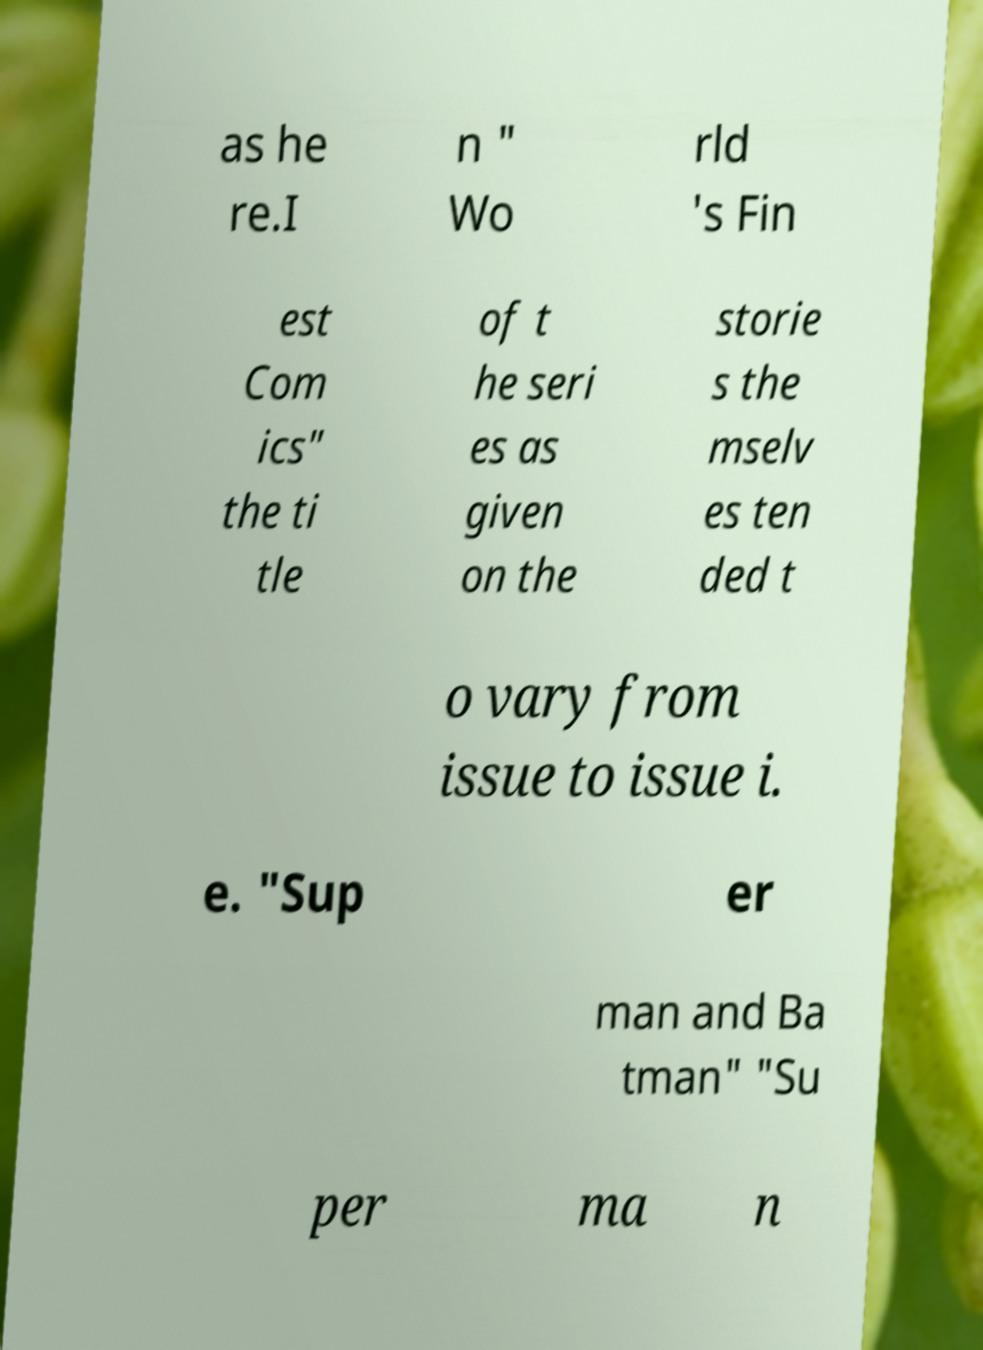Could you extract and type out the text from this image? as he re.I n " Wo rld 's Fin est Com ics" the ti tle of t he seri es as given on the storie s the mselv es ten ded t o vary from issue to issue i. e. "Sup er man and Ba tman" "Su per ma n 